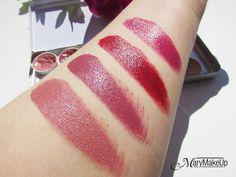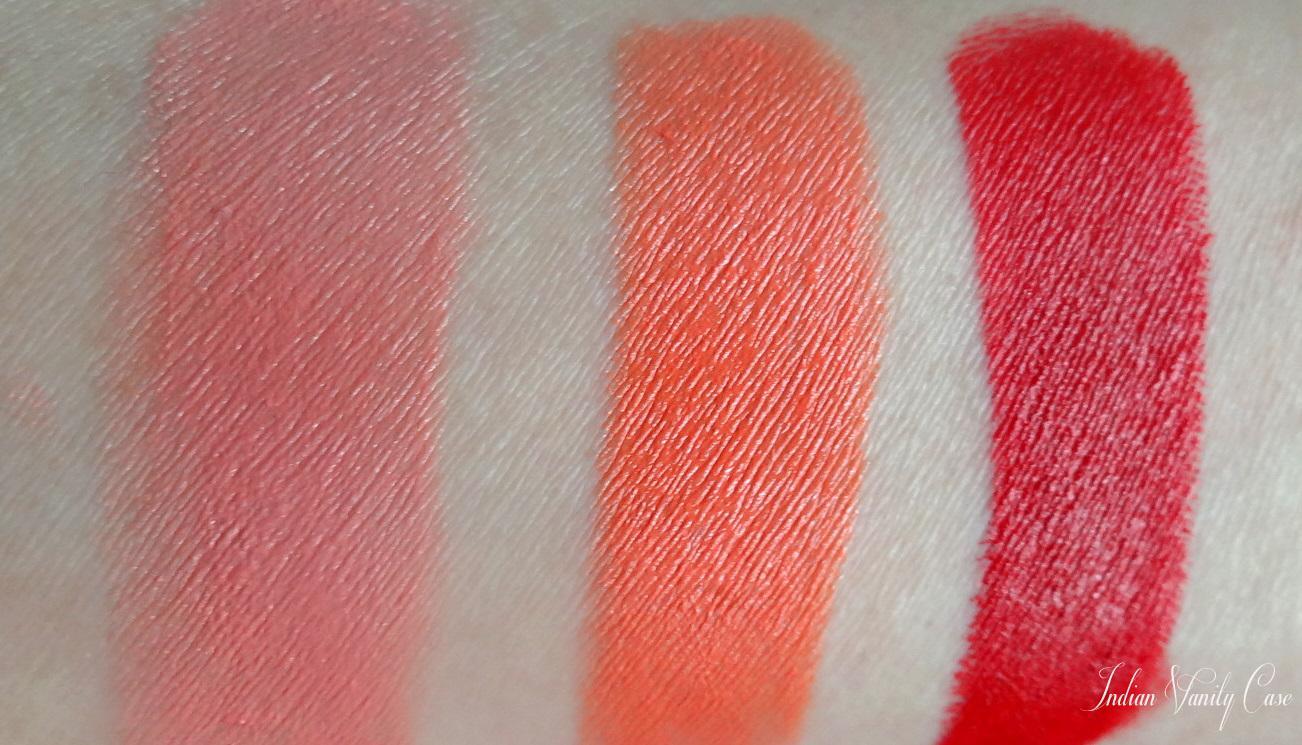The first image is the image on the left, the second image is the image on the right. Analyze the images presented: Is the assertion "One arm has 4 swatches on it." valid? Answer yes or no. Yes. The first image is the image on the left, the second image is the image on the right. For the images displayed, is the sentence "Each image shows lipstick stripe marks on pale skin displayed vertically, and each image includes at least five different stripes of color." factually correct? Answer yes or no. No. 